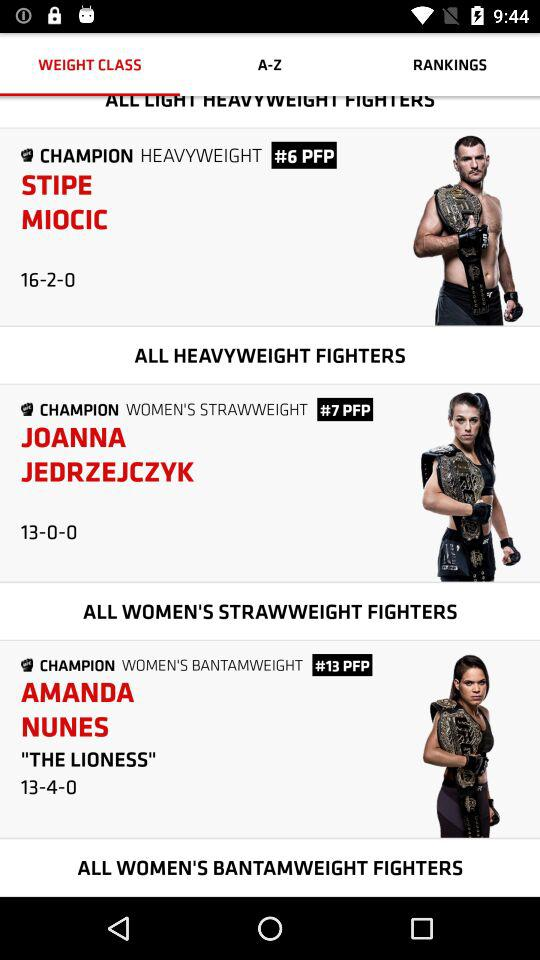Could you tell me more about Amanda Nunes' achievements in her career? Amanda Nunes, holding the title in the Women's Bantamweight division, is celebrated for her powerful striking and strategic skillset. She's uniquely distinguished by being a champion in multiple weight classes, reflecting her versatility and dominance in women's MMA. 